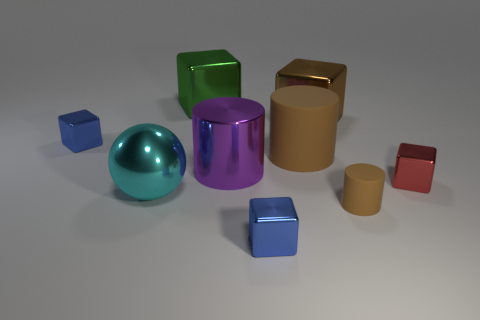How many large brown things are behind the big object to the right of the large brown cylinder? Behind the big object to the right of the large brown cylinder, there are no large brown items. The area in question is clear of any such objects, so the number of large brown things in that specific location is zero. 